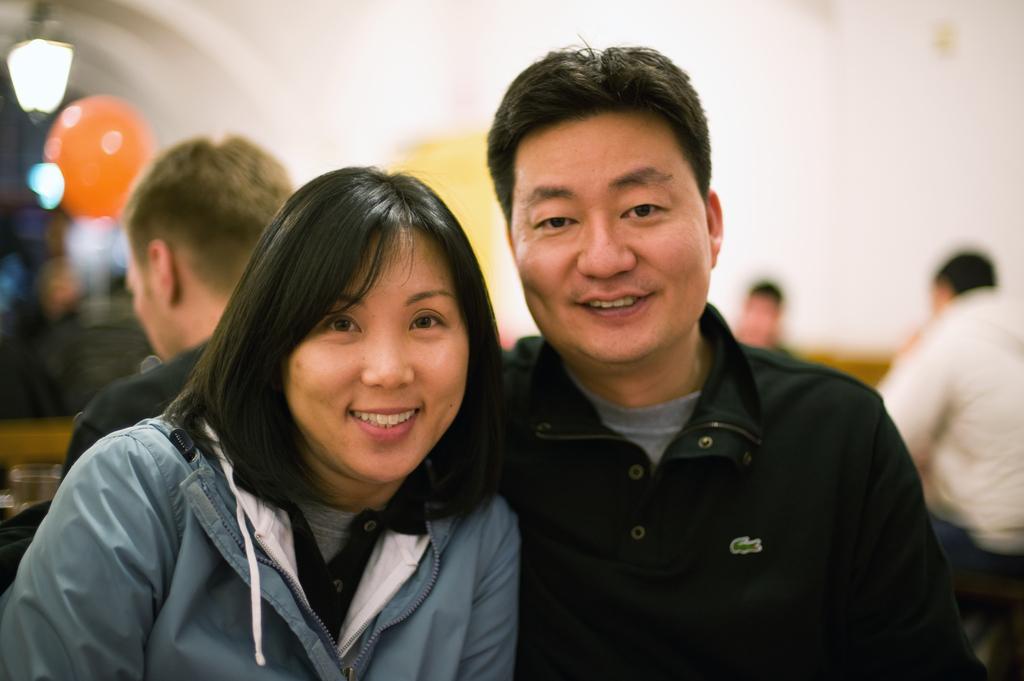In one or two sentences, can you explain what this image depicts? In this image we can see a man and a woman. In the background there are few people. And it is blurry in the background. 